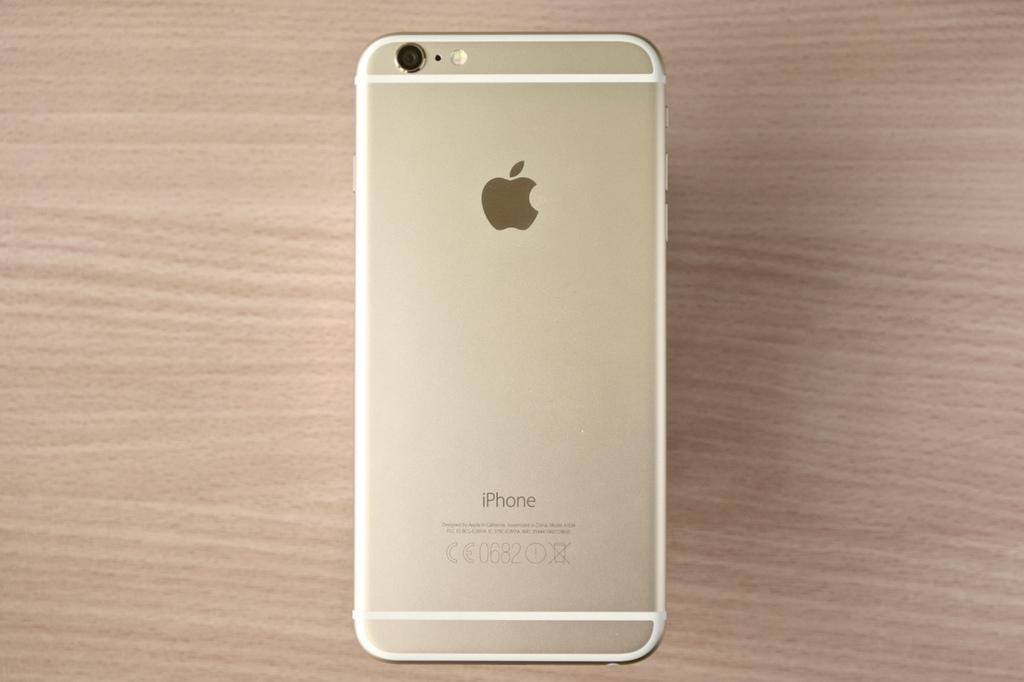<image>
Describe the image concisely. An iPhone, with the numbers 0682 on the back of it, is on a wooden surfaec. 